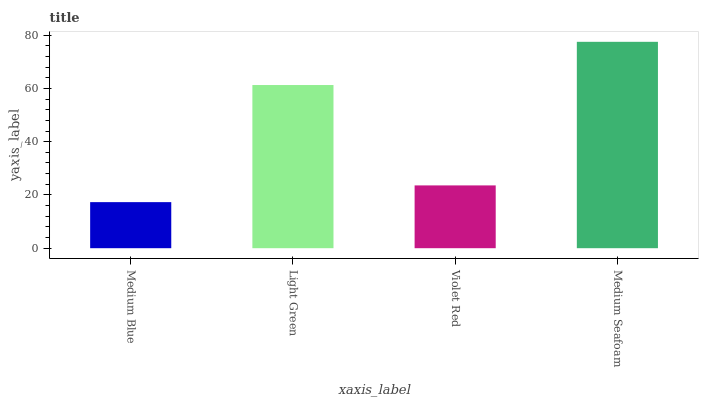Is Light Green the minimum?
Answer yes or no. No. Is Light Green the maximum?
Answer yes or no. No. Is Light Green greater than Medium Blue?
Answer yes or no. Yes. Is Medium Blue less than Light Green?
Answer yes or no. Yes. Is Medium Blue greater than Light Green?
Answer yes or no. No. Is Light Green less than Medium Blue?
Answer yes or no. No. Is Light Green the high median?
Answer yes or no. Yes. Is Violet Red the low median?
Answer yes or no. Yes. Is Medium Seafoam the high median?
Answer yes or no. No. Is Medium Blue the low median?
Answer yes or no. No. 